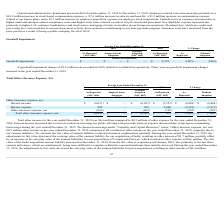From Avalara's financial document, What are the total income for the year ended December 31, 2019 and the other expense for the year ended December 31, 2018 respectively? The document shows two values: $6.6 million and $0.5 million. From the document: "er income for the year ended December 31, 2019 was $6.6 million compared to $0.5 million of other expense for the year ended December 31, ded December..." Also, What caused the increase in interest income and decrease in interest expense for the year ended 31 December 2019 respectively? The document shows two values: interest earned on investing our public offering cash proceeds and having no outstanding borrowings during the year. From the document: "2018. Interest income increased due to interest earned on investing our public offering cash proceeds. Interest expense decreased due to having no out..." Also, What are the net other (income) expense for the years ended December 31, 2019 and 2018 respectively? The document shows two values: $0.9 million and $0.6 million. From the document: "me in the year ended December 31, 2019 compared to $0.6 million of other income in the year ended December 31, 2018, primarily due to our earnout liab..." Also, can you calculate: What is the percentage change in net other (income) expenses between 2018 and 2019? To answer this question, I need to perform calculations using the financial data. The calculation is: (0.9 - 0.6)/0.6 , which equals 50 (percentage). This is based on the information: "esources” below. Other (income) expense, net was $0.9 million other income in the year ended December 31, 2019 compared to $0.6 million of other income i in the year ended December 31, 2019 compared t..." The key data points involved are: 0.6, 0.9. Also, can you calculate: What is the difference in the company's total other (income) expense in 2019 under ASC 606 and ASC 605? I cannot find a specific answer to this question in the financial document. Also, can you calculate: What is the value of the 2018 as reported value as a percentage of the 2019 as reported value of total net other (income) expense? To answer this question, I need to perform calculations using the financial data. The calculation is: 472/-6,613 , which equals -7.14 (percentage). This is based on the information: "r (income) expense, net $ (6,613) $ — $ (6,613) $ 472 $ (7,085) $ (7,085) Total other (income) expense, net $ (6,613) $ — $ (6,613) $ 472 $ (7,085) $ (7,085)..." The key data points involved are: 472, 6,613. 